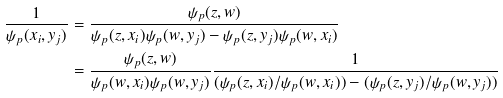<formula> <loc_0><loc_0><loc_500><loc_500>\frac { 1 } { \psi _ { p } ( x _ { i } , y _ { j } ) } & = \frac { \psi _ { p } ( z , w ) } { \psi _ { p } ( z , x _ { i } ) \psi _ { p } ( w , y _ { j } ) - \psi _ { p } ( z , y _ { j } ) \psi _ { p } ( w , x _ { i } ) } \\ & = \frac { \psi _ { p } ( z , w ) } { \psi _ { p } ( w , x _ { i } ) \psi _ { p } ( w , y _ { j } ) } \frac { 1 } { ( \psi _ { p } ( z , x _ { i } ) / \psi _ { p } ( w , x _ { i } ) ) - ( \psi _ { p } ( z , y _ { j } ) / \psi _ { p } ( w , y _ { j } ) ) }</formula> 